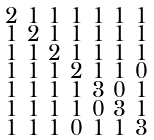Convert formula to latex. <formula><loc_0><loc_0><loc_500><loc_500>\begin{smallmatrix} 2 & 1 & 1 & 1 & 1 & 1 & 1 \\ 1 & 2 & 1 & 1 & 1 & 1 & 1 \\ 1 & 1 & 2 & 1 & 1 & 1 & 1 \\ 1 & 1 & 1 & 2 & 1 & 1 & 0 \\ 1 & 1 & 1 & 1 & 3 & 0 & 1 \\ 1 & 1 & 1 & 1 & 0 & 3 & 1 \\ 1 & 1 & 1 & 0 & 1 & 1 & 3 \end{smallmatrix}</formula> 